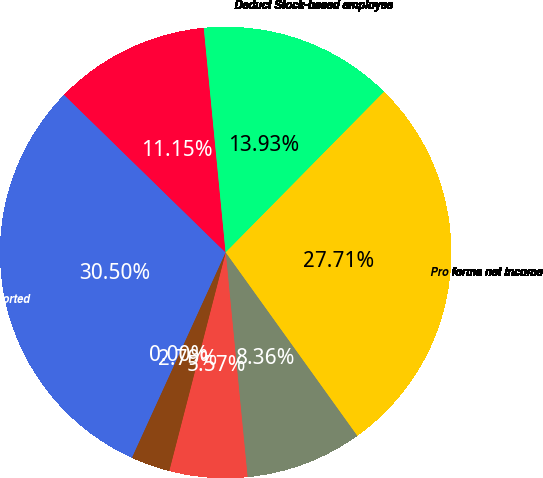<chart> <loc_0><loc_0><loc_500><loc_500><pie_chart><fcel>Net income as reported<fcel>Add Stock-based compensation<fcel>Deduct Stock-based employee<fcel>Pro forma net income<fcel>Basic - as reported<fcel>Basic - pro forma<fcel>Diluted - as reported<fcel>Diluted - pro forma<nl><fcel>30.5%<fcel>11.15%<fcel>13.93%<fcel>27.71%<fcel>8.36%<fcel>5.57%<fcel>2.79%<fcel>0.0%<nl></chart> 